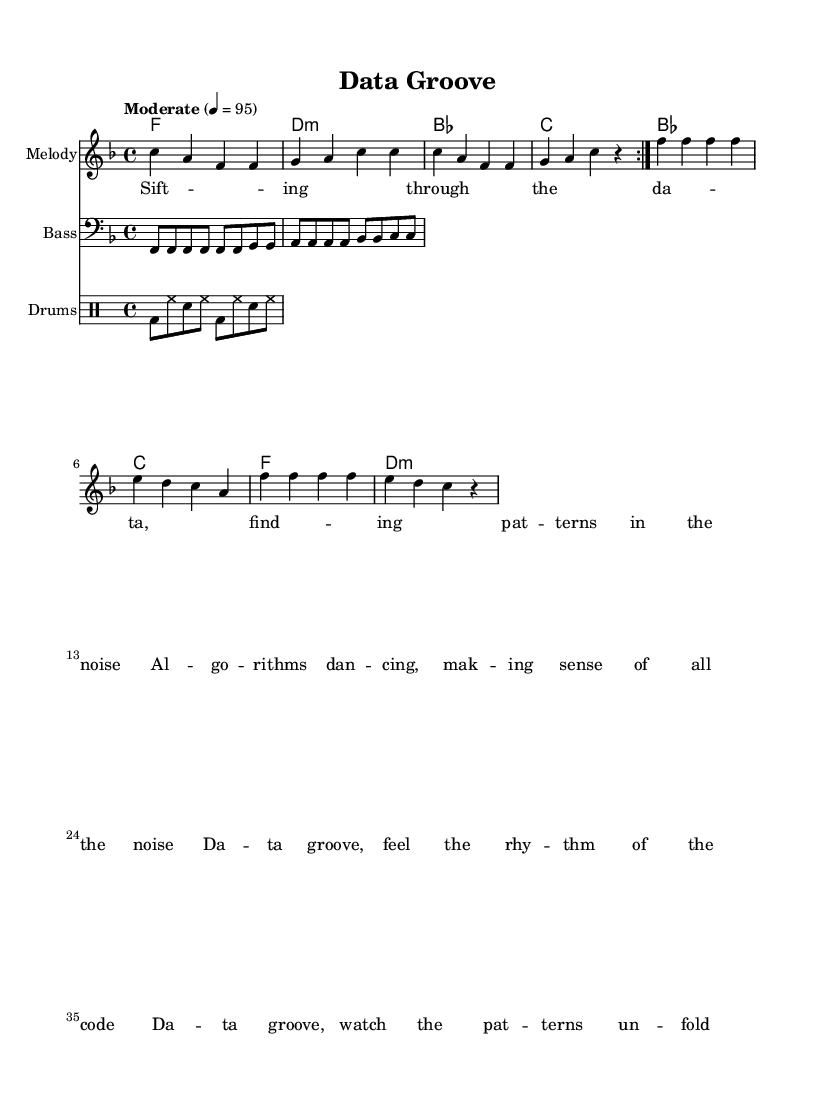What is the key signature of this music? The key signature is F major, which has one flat (B flat). This can be identified in the global section of the code where it is specified as `\key f \major`.
Answer: F major What is the time signature of this music? The time signature is 4/4, indicated in the global section by `\time 4/4`. This indicates that there are four beats in each measure and a quarter note gets one beat.
Answer: 4/4 What is the tempo marking for this piece? The tempo marking is set to "Moderate", with a BPM of 95, as specified in the global section: `\tempo "Moderate" 4 = 95`. This indicates the speed at which the piece should be played.
Answer: Moderate, 95 How many times does the melody repeat in this piece? The melody is repeated two times, shown by the `\repeat volta 2` directive in the melody section of the sheet music code. This means the section should be played twice before moving on.
Answer: 2 What is the first lyric line of the song? The first lyric line is "Sifting through the data, finding patterns in the noise." This can be found in the verse section of the code, where the lyrics are explicitly defined.
Answer: Sifting through the data, finding patterns in the noise What is the instrument used for the bass part? The bass part is indicated to be played in the bass clef, which is specified in the `\clef bass` directive within the bass section of the music code. This suggests the part is for a bass instrument.
Answer: Bass How many different chords are indicated in the chord progression? There are four different chord types indicated in the chord progression: F major, D minor, B flat major, and C major. This is described in the chordNames section with each chord listed individually.
Answer: 4 